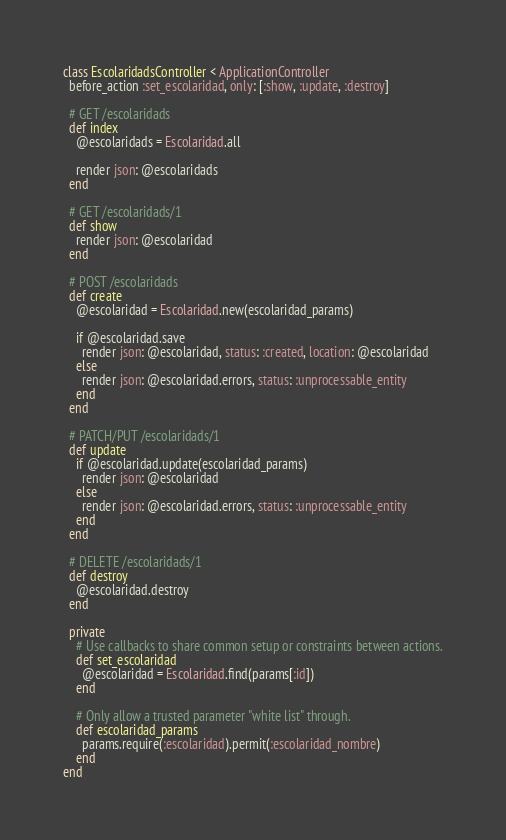Convert code to text. <code><loc_0><loc_0><loc_500><loc_500><_Ruby_>class EscolaridadsController < ApplicationController
  before_action :set_escolaridad, only: [:show, :update, :destroy]

  # GET /escolaridads
  def index
    @escolaridads = Escolaridad.all

    render json: @escolaridads
  end

  # GET /escolaridads/1
  def show
    render json: @escolaridad
  end

  # POST /escolaridads
  def create
    @escolaridad = Escolaridad.new(escolaridad_params)

    if @escolaridad.save
      render json: @escolaridad, status: :created, location: @escolaridad
    else
      render json: @escolaridad.errors, status: :unprocessable_entity
    end
  end

  # PATCH/PUT /escolaridads/1
  def update
    if @escolaridad.update(escolaridad_params)
      render json: @escolaridad
    else
      render json: @escolaridad.errors, status: :unprocessable_entity
    end
  end

  # DELETE /escolaridads/1
  def destroy
    @escolaridad.destroy
  end

  private
    # Use callbacks to share common setup or constraints between actions.
    def set_escolaridad
      @escolaridad = Escolaridad.find(params[:id])
    end

    # Only allow a trusted parameter "white list" through.
    def escolaridad_params
      params.require(:escolaridad).permit(:escolaridad_nombre)
    end
end
</code> 